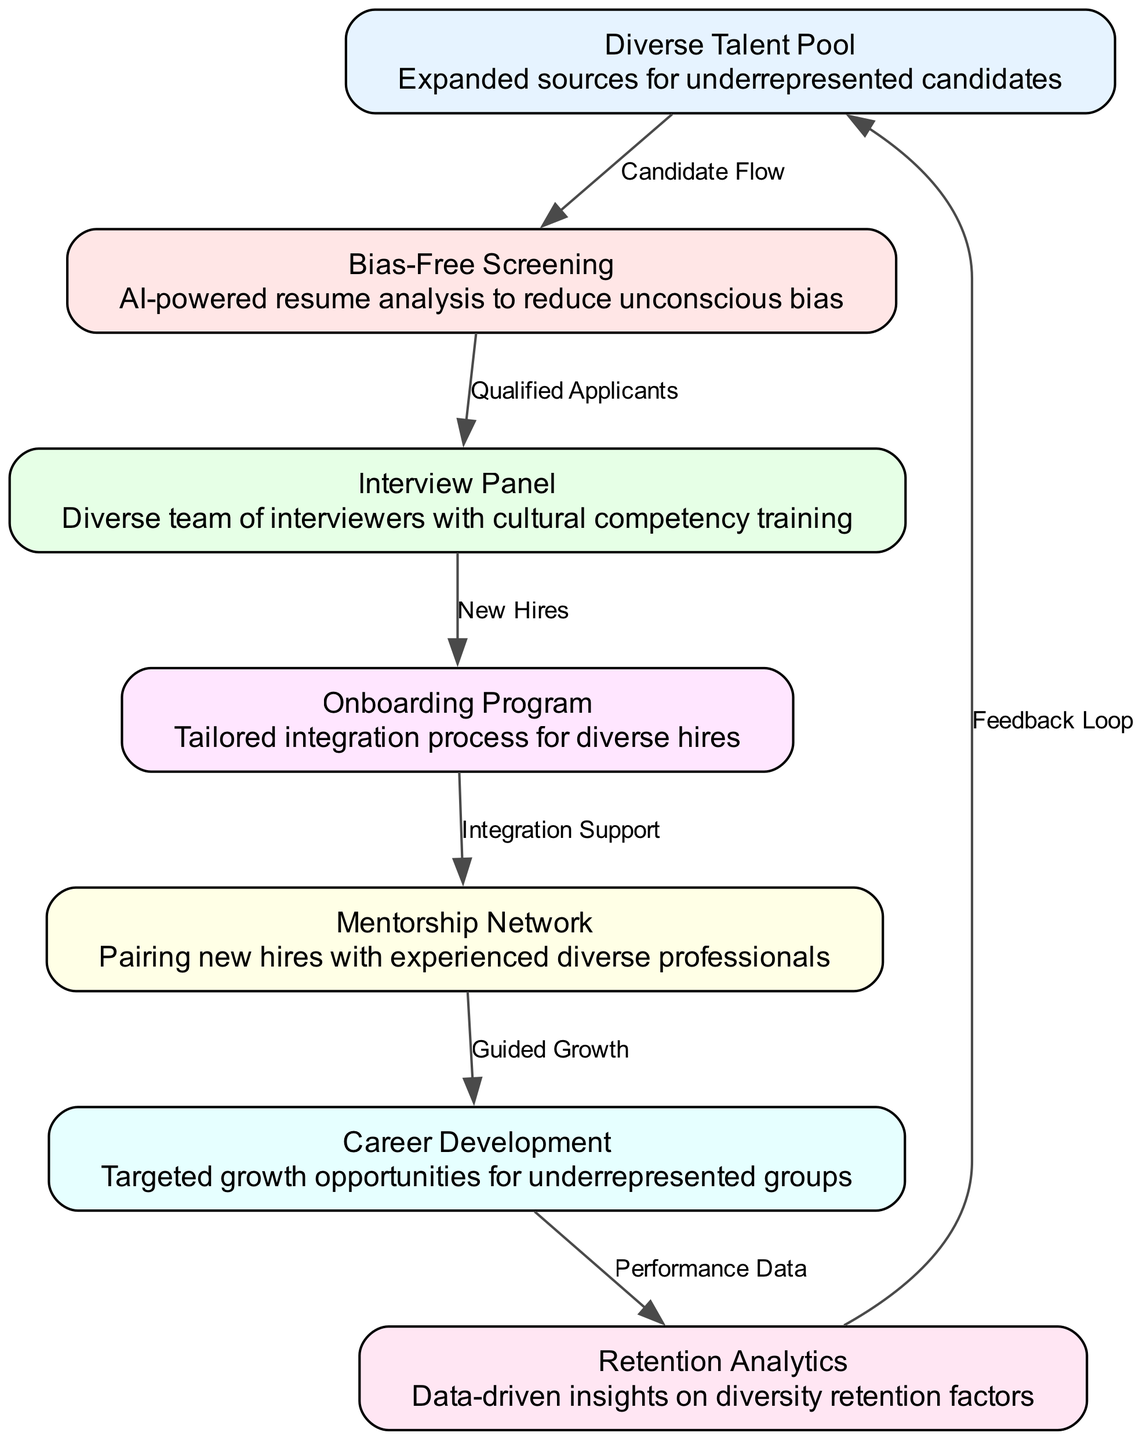What is the first node in the diagram? The diagram starts with the node labeled "Diverse Talent Pool." It is identified as the initial step in the recruitment process, indicating that the flow begins by expanding sources for underrepresented candidates.
Answer: Diverse Talent Pool How many nodes are present in the diagram? By counting the individual nodes listed in the diagram, there are a total of seven nodes described, each representing a key component of the recruitment and retention system.
Answer: 7 What is the relationship between "Bias-Free Screening" and "Interview Panel"? The edge connecting "Bias-Free Screening" to "Interview Panel" is labeled "Qualified Applicants." This indicates that following the screening process, the qualified candidates proceed to the interview stage.
Answer: Qualified Applicants Which node addresses retention in the system? The node that focuses specifically on retention is labeled "Retention Analytics," which provides data-driven insights into factors affecting diversity retention.
Answer: Retention Analytics What process follows the "Onboarding Program"? According to the flow of the diagram, the process that follows the "Onboarding Program" node is the "Mentorship Network," indicating a support structure for new hires.
Answer: Mentorship Network How is feedback incorporated back into the system? The “Feedback Loop” is connected from "Retention Analytics" back to "Diverse Talent Pool," illustrating that insights gained from retention analytics inform the initial recruitment strategy, thus creating a cyclical improvement process.
Answer: Feedback Loop What does the "Mentorship Network" lead to? The "Mentorship Network" leads to the "Career Development" node, suggesting that mentoring assists in providing targeted growth opportunities for underrepresented groups within the company.
Answer: Career Development What is the function of the "Career Development" node? The "Career Development" node focuses on providing targeted growth opportunities specifically designed for underrepresented groups, enhancing their career paths within the company.
Answer: Targeted growth opportunities 